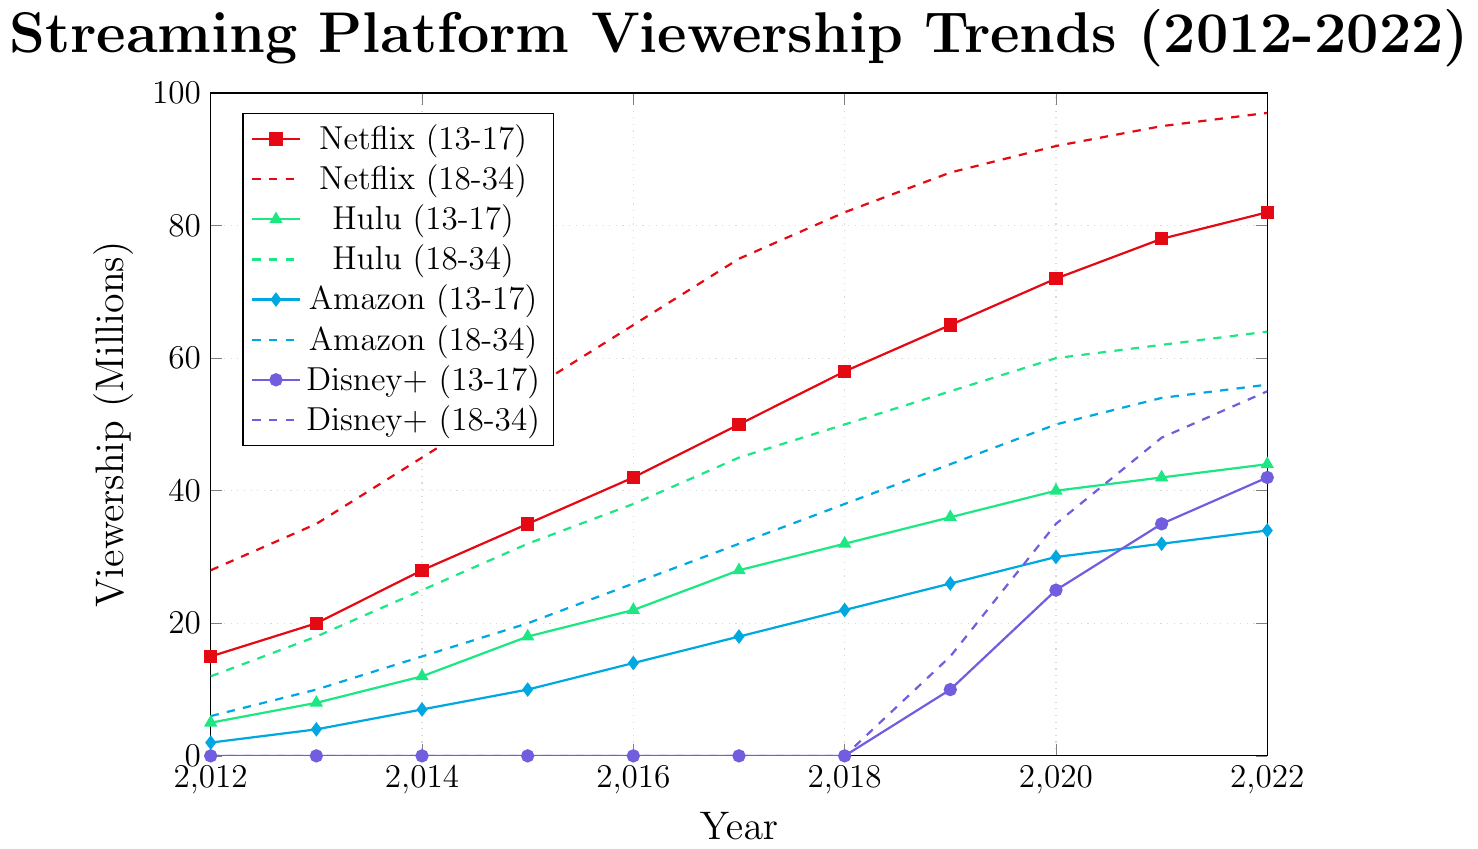What is the general trend in viewership for Netflix among the 18-34 age group from 2012 to 2022? The trend line for Netflix in the 18-34 age group shows a consistent increase in viewership from 28 million in 2012 to 97 million in 2022.
Answer: Increase How did the viewership for Disney+ in the 13-17 age group change between 2019 and 2022? Disney+ viewership among the 13-17 age group starts at 10 million in 2019, increases to 25 million in 2020, then rises to 35 million in 2021, and finally reaches 42 million in 2022.
Answer: Increased by 32 million Which streaming platform had the highest viewership in 2022 for the 35-49 age group? Looking at the lines representing the 35-49 age group, Netflix reaches 85 million in 2022, Hulu reaches 57 million, Amazon reaches 52 million, and Disney+ reaches 48 million.
Answer: Netflix Which age group shows the slowest growth in Amazon Prime viewership from 2012 to 2022? Examining the Amazon viewership lines from 2012 to 2022, the 50+ age group grows from 2 million to 30 million; the 35-49 group from 5 million to 52 million; the 18-34 group from 6 million to 56 million; and the 13-17 group from 2 million to 34 million.
Answer: 50+ By how much did the viewership for Hulu in the 18-34 age group surpass that in the 35-49 age group in 2022? Hulu's viewership for 18-34 in 2022 is 64 million and for 35-49 it’s 57 million. The difference is 64 - 57.
Answer: 7 million What was the viewership difference for Netflix in the 13-17 age group between 2012 and 2022? Netflix viewership among the 13-17 age group in 2012 is 15 million and in 2022 it’s 82 million. The difference is 82 - 15.
Answer: 67 million Which age group experienced the most significant increase in Hulu's viewership from 2016 to 2022? In 2016, viewership for Hulu is 22 million (13-17), 38 million (18-34), 30 million (35-49), and 15 million (50+). In 2022, these numbers are 44 million, 64 million, 57 million, and 34 million respectively. The increases are 22, 26, 27, and 19 million.
Answer: 35-49 Compare the trends of Netflix and Disney+ for the 18-34 age group from 2019 to 2022. For Netflix, the viewership increases from 88 million in 2019 to 97 million in 2022. For Disney+, it starts at 15 million in 2019 and increases to 55 million in 2022. Both show an increasing trend, but Netflix has higher values throughout.
Answer: Both increase, Netflix has higher numbers What was the total viewership for all age groups combined for Amazon Prime in 2020? Adding Amazon Prime viewership for all age groups in 2020: 13-17 (30M), 18-34 (50M), 35-49 (46M), 50+ (26M). Total is 30 + 50 + 46 + 26.
Answer: 152 million 